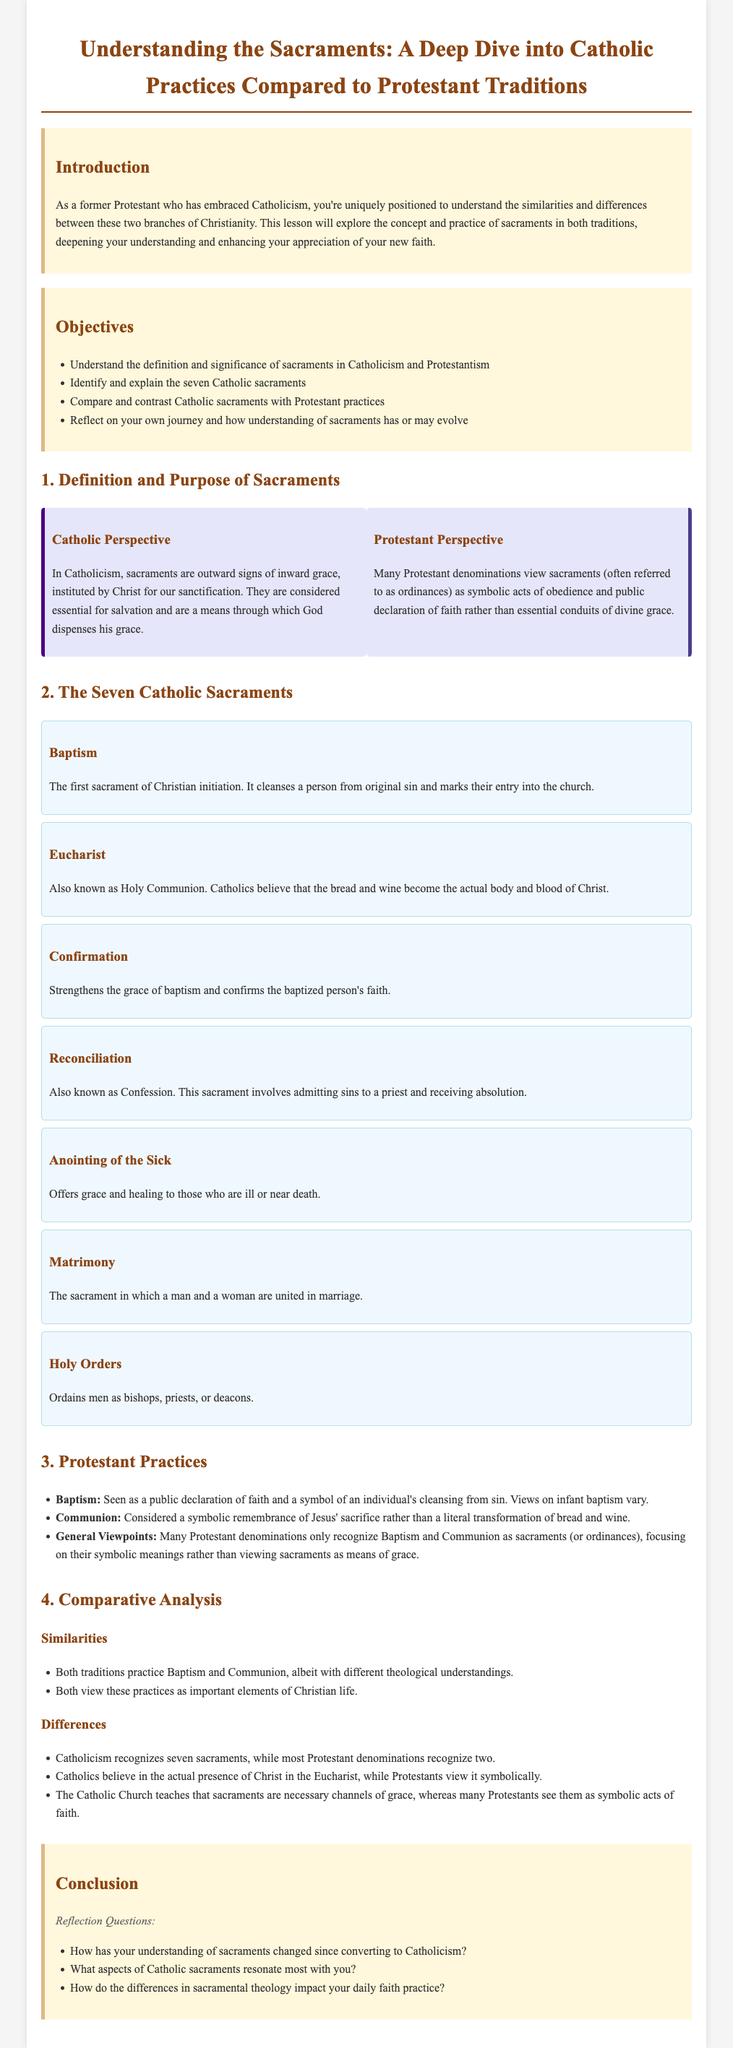What are the seven Catholic sacraments? The document lists the seven sacraments as Baptism, Eucharist, Confirmation, Reconciliation, Anointing of the Sick, Matrimony, and Holy Orders.
Answer: Baptism, Eucharist, Confirmation, Reconciliation, Anointing of the Sick, Matrimony, Holy Orders What do Catholics believe about the Eucharist? The document states that Catholics believe that the bread and wine become the actual body and blood of Christ.
Answer: Actual body and blood of Christ How many sacraments do most Protestant denominations recognize? The document mentions that most Protestant denominations recognize only two sacraments (Baptism and Communion).
Answer: Two What is considered the first sacrament of Christian initiation? The document specifies that Baptism is the first sacrament of Christian initiation.
Answer: Baptism What is the purpose of the sacrament of Reconciliation? According to the document, the purpose is to admit sins to a priest and receive absolution.
Answer: Admit sins to a priest and receive absolution In terms of sacramental theology, what is a major difference between Catholicism and Protestantism? The document states that Catholics see sacraments as necessary channels of grace, while many Protestants view them as symbolic acts of faith.
Answer: Necessary channels of grace vs. symbolic acts of faith What is one of the reflection questions posed in the conclusion? The document lists reflection questions, one of which is about how understanding of sacraments has changed since converting to Catholicism.
Answer: How has your understanding of sacraments changed since converting to Catholicism? How does the document categorize sacraments from a Protestant viewpoint? The document states that many Protestant denominations refer to sacraments as ordinances and view them as symbolic acts of obedience.
Answer: Ordinances and symbolic acts of obedience 